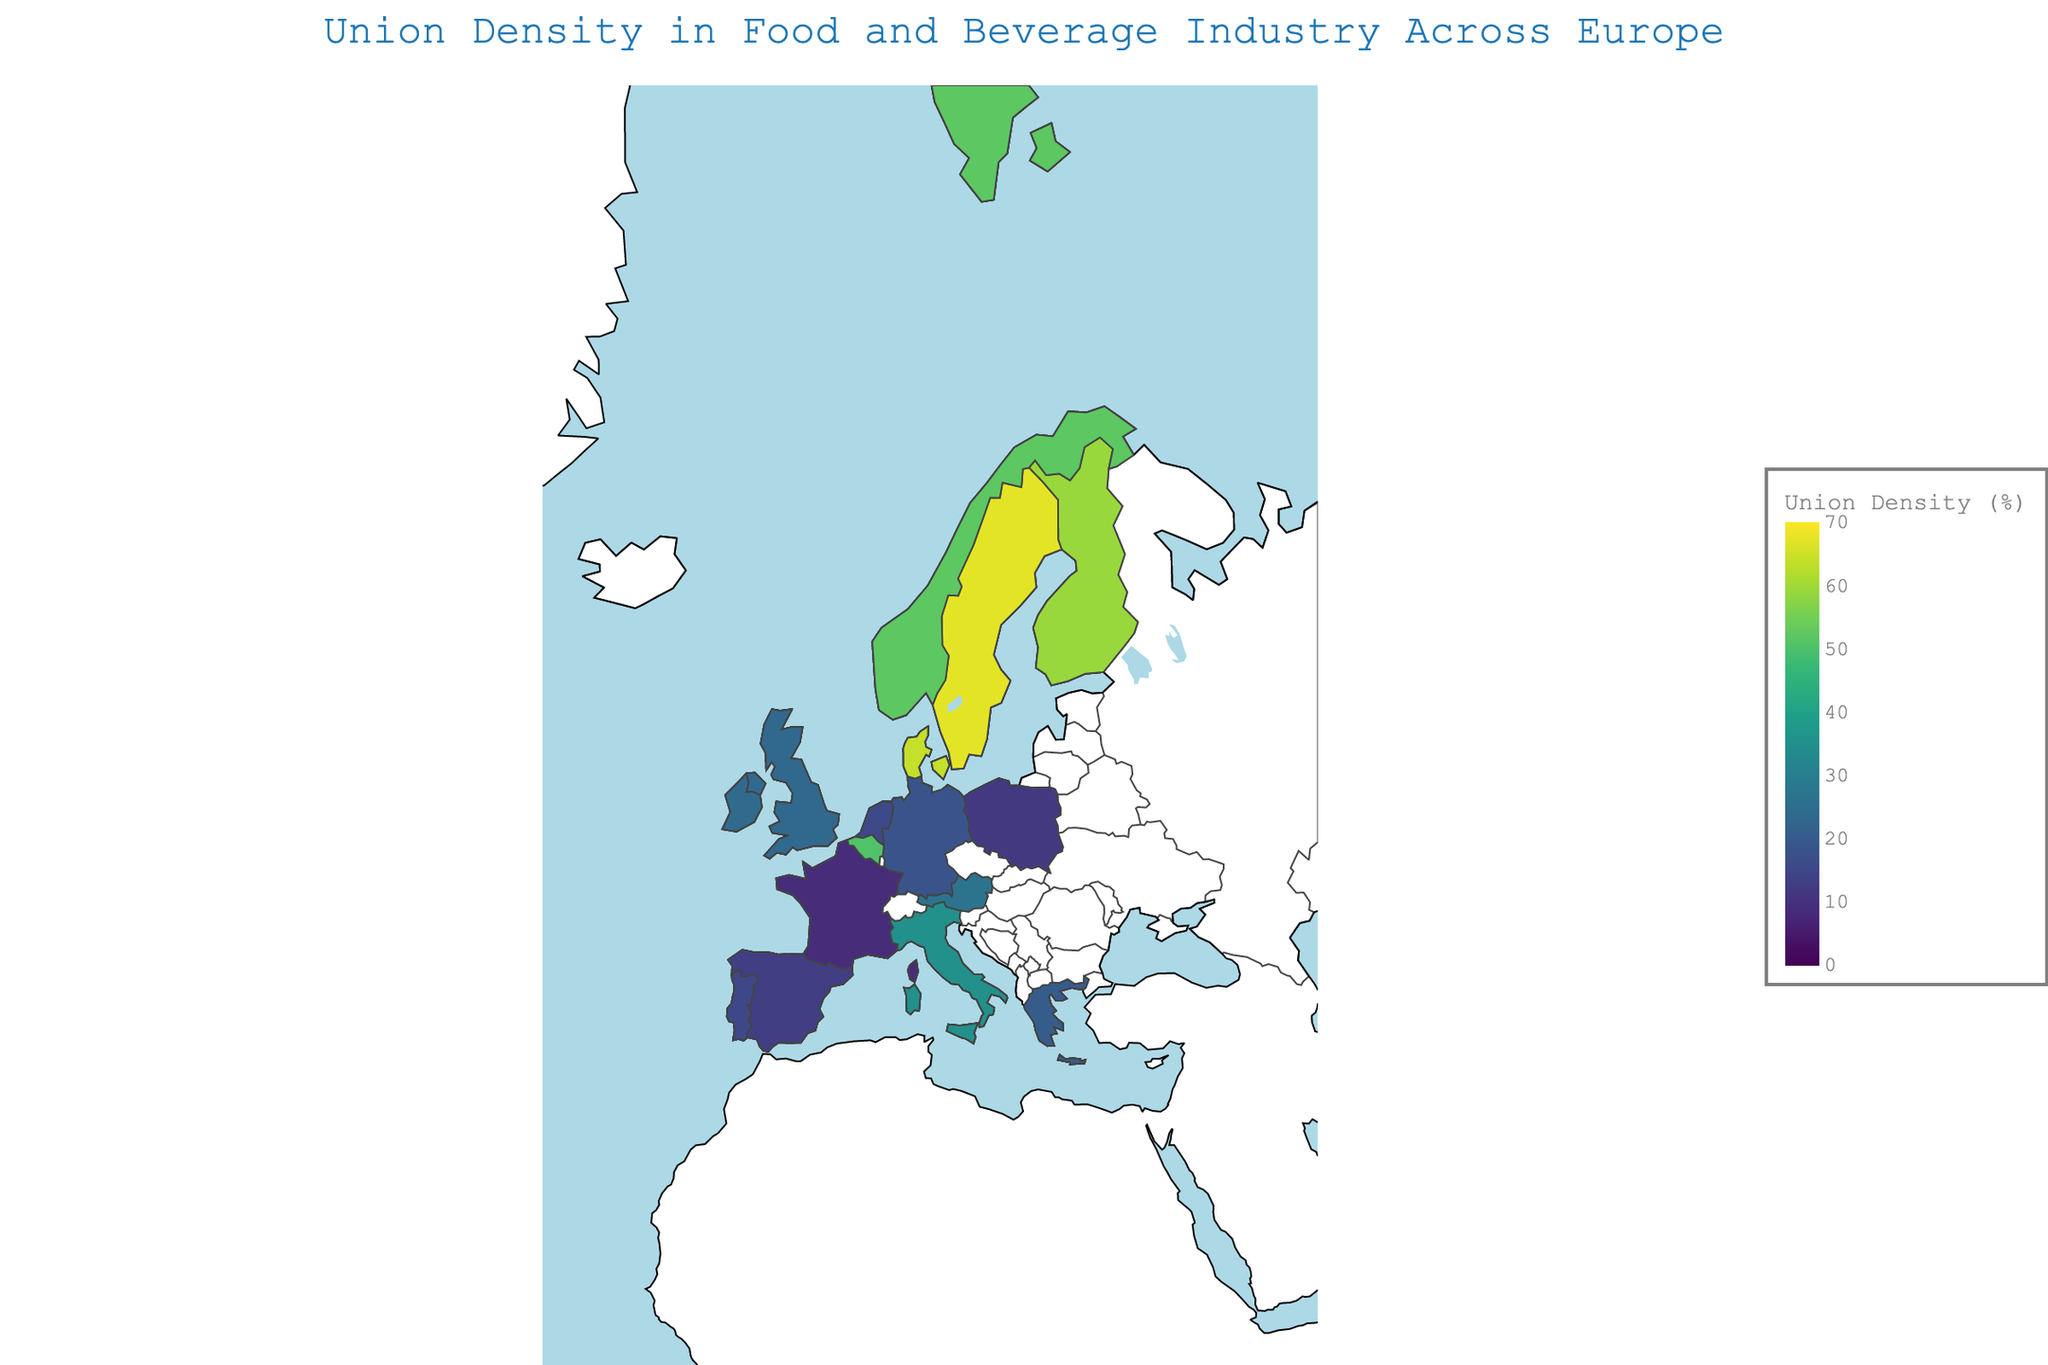Which country has the highest union density percentage? By examining the color and the hover data in the figure, we can see the country with the darkest color and highest percentage value.
Answer: Sweden What is the title of this map? By reading the title text centered at the top of the figure.
Answer: "Union Density in Food and Beverage Industry Across Europe" Which country has a union density percentage close to 20%? By inspecting the hover data on the map, we can find countries with values near 20%. Greece has a union density of 20.2%.
Answer: Greece How does union density in Germany compare to that in Denmark? By comparing the hover data of both countries, we see that Germany has 18.2% union density while Denmark has 63.8%. Germany's union density is much lower.
Answer: Germany's is lower What is the average union density percentage in the Nordic countries (Sweden, Denmark, Finland, and Norway)? Calculate the average by summing the union densities of these countries (67.3 + 63.8 + 59.2 + 52.1) and dividing by the number of countries (4). The sum is 242.4, so the average is 242.4 / 4 = 60.6.
Answer: 60.6 Which countries have a union density percentage less than 15%? Identify countries with percentages less than 15% from the hover data: France (8.7%), Spain (12.9%), and Poland (11.8%).
Answer: France, Spain, Poland What is the difference in union density percentage between Italy and the Netherlands? Subtract the union density of Netherlands (15.6%) from that of Italy (35.4%). The difference is 35.4 - 15.6 = 19.8.
Answer: 19.8 Name two countries with relatively similar union densities around 25%. Look for countries with values around 25% from the hover data: United Kingdom with 23.5% and Ireland with 24.1%.
Answer: United Kingdom, Ireland Which country shows a union density of exactly 50.3%? Find the country with the exact value in the hover data. It's Belgium.
Answer: Belgium Among Germany, France, and Poland, which country has the highest union density percentage? Compare the union densities: Germany (18.2%), France (8.7%), and Poland (11.8%). Germany has the highest.
Answer: Germany 